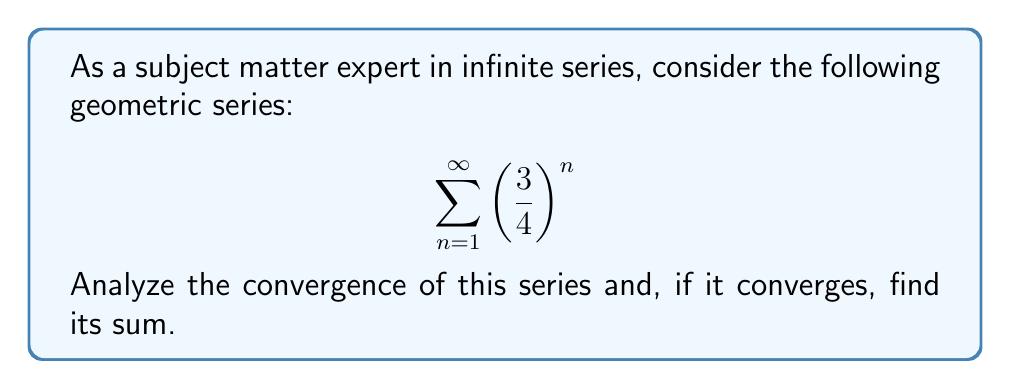Solve this math problem. To analyze the convergence of this infinite geometric series, we'll follow these steps:

1) First, let's identify the components of the geometric series:
   - The first term, $a = \frac{3}{4}$
   - The common ratio, $r = \frac{3}{4}$

2) For a geometric series to converge, the absolute value of the common ratio must be less than 1:

   $|r| < 1$

   In this case, $|\frac{3}{4}| = \frac{3}{4} < 1$, so this condition is satisfied.

3) Since $|r| < 1$, we can conclude that the series converges.

4) For a converging geometric series, we can find the sum using the formula:

   $$S_{\infty} = \frac{a}{1-r}$$

   where $S_{\infty}$ is the sum of the infinite series, $a$ is the first term, and $r$ is the common ratio.

5) Substituting our values:

   $$S_{\infty} = \frac{\frac{3}{4}}{1-\frac{3}{4}}$$

6) Simplify:
   $$S_{\infty} = \frac{\frac{3}{4}}{\frac{1}{4}} = 3$$

Therefore, the series converges to a sum of 3.
Answer: The series converges, and its sum is 3. 